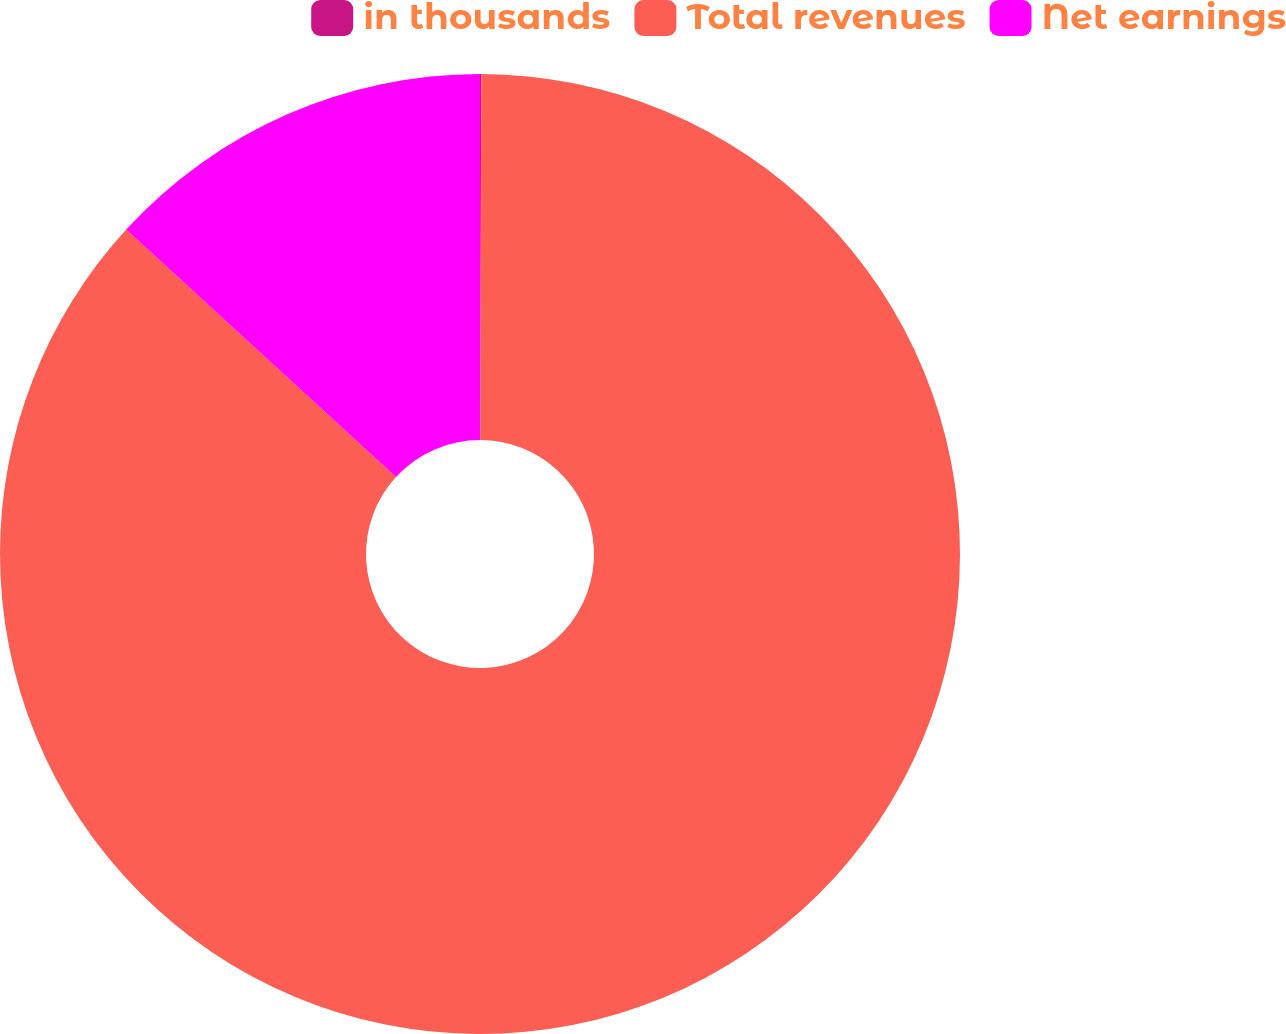Convert chart to OTSL. <chart><loc_0><loc_0><loc_500><loc_500><pie_chart><fcel>in thousands<fcel>Total revenues<fcel>Net earnings<nl><fcel>0.04%<fcel>86.77%<fcel>13.19%<nl></chart> 